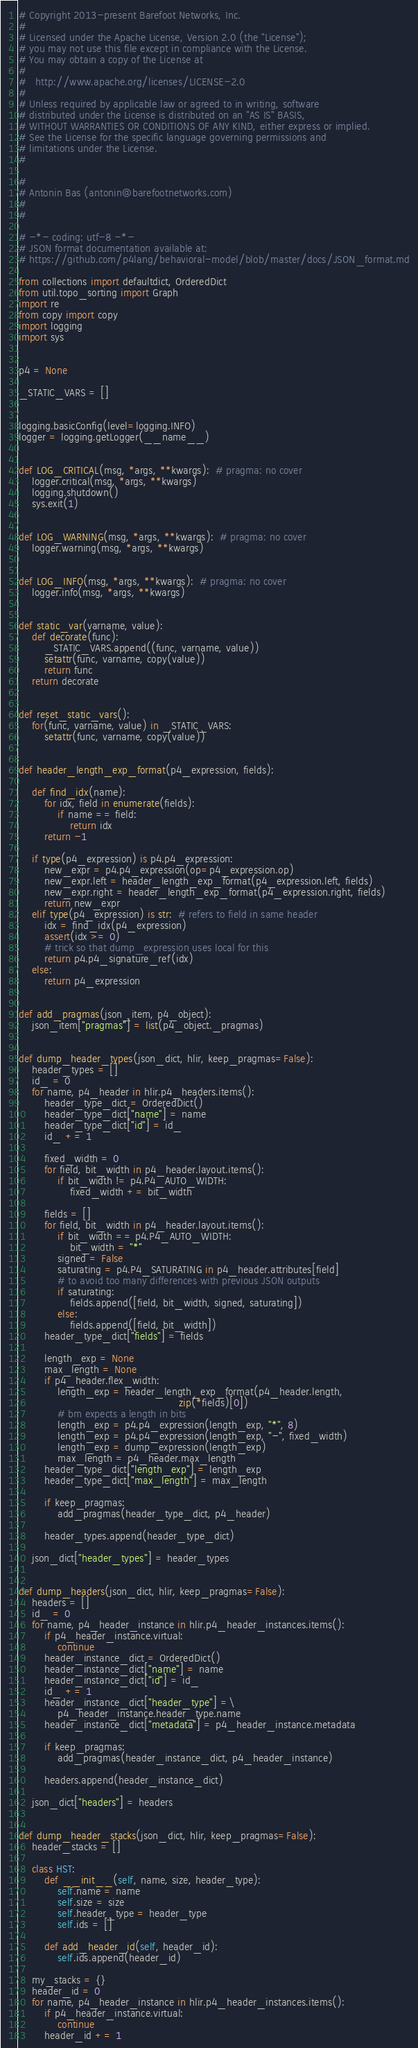<code> <loc_0><loc_0><loc_500><loc_500><_Python_># Copyright 2013-present Barefoot Networks, Inc.
#
# Licensed under the Apache License, Version 2.0 (the "License");
# you may not use this file except in compliance with the License.
# You may obtain a copy of the License at
#
#   http://www.apache.org/licenses/LICENSE-2.0
#
# Unless required by applicable law or agreed to in writing, software
# distributed under the License is distributed on an "AS IS" BASIS,
# WITHOUT WARRANTIES OR CONDITIONS OF ANY KIND, either express or implied.
# See the License for the specific language governing permissions and
# limitations under the License.
#

#
# Antonin Bas (antonin@barefootnetworks.com)
#
#

# -*- coding: utf-8 -*-
# JSON format documentation available at:
# https://github.com/p4lang/behavioral-model/blob/master/docs/JSON_format.md

from collections import defaultdict, OrderedDict
from util.topo_sorting import Graph
import re
from copy import copy
import logging
import sys


p4 = None

_STATIC_VARS = []


logging.basicConfig(level=logging.INFO)
logger = logging.getLogger(__name__)


def LOG_CRITICAL(msg, *args, **kwargs):  # pragma: no cover
    logger.critical(msg, *args, **kwargs)
    logging.shutdown()
    sys.exit(1)


def LOG_WARNING(msg, *args, **kwargs):  # pragma: no cover
    logger.warning(msg, *args, **kwargs)


def LOG_INFO(msg, *args, **kwargs):  # pragma: no cover
    logger.info(msg, *args, **kwargs)


def static_var(varname, value):
    def decorate(func):
        _STATIC_VARS.append((func, varname, value))
        setattr(func, varname, copy(value))
        return func
    return decorate


def reset_static_vars():
    for(func, varname, value) in _STATIC_VARS:
        setattr(func, varname, copy(value))


def header_length_exp_format(p4_expression, fields):

    def find_idx(name):
        for idx, field in enumerate(fields):
            if name == field:
                return idx
        return -1

    if type(p4_expression) is p4.p4_expression:
        new_expr = p4.p4_expression(op=p4_expression.op)
        new_expr.left = header_length_exp_format(p4_expression.left, fields)
        new_expr.right = header_length_exp_format(p4_expression.right, fields)
        return new_expr
    elif type(p4_expression) is str:  # refers to field in same header
        idx = find_idx(p4_expression)
        assert(idx >= 0)
        # trick so that dump_expression uses local for this
        return p4.p4_signature_ref(idx)
    else:
        return p4_expression


def add_pragmas(json_item, p4_object):
    json_item["pragmas"] = list(p4_object._pragmas)


def dump_header_types(json_dict, hlir, keep_pragmas=False):
    header_types = []
    id_ = 0
    for name, p4_header in hlir.p4_headers.items():
        header_type_dict = OrderedDict()
        header_type_dict["name"] = name
        header_type_dict["id"] = id_
        id_ += 1

        fixed_width = 0
        for field, bit_width in p4_header.layout.items():
            if bit_width != p4.P4_AUTO_WIDTH:
                fixed_width += bit_width

        fields = []
        for field, bit_width in p4_header.layout.items():
            if bit_width == p4.P4_AUTO_WIDTH:
                bit_width = "*"
            signed = False
            saturating = p4.P4_SATURATING in p4_header.attributes[field]
            # to avoid too many differences with previous JSON outputs
            if saturating:
                fields.append([field, bit_width, signed, saturating])
            else:
                fields.append([field, bit_width])
        header_type_dict["fields"] = fields

        length_exp = None
        max_length = None
        if p4_header.flex_width:
            length_exp = header_length_exp_format(p4_header.length,
                                                  zip(*fields)[0])
            # bm expects a length in bits
            length_exp = p4.p4_expression(length_exp, "*", 8)
            length_exp = p4.p4_expression(length_exp, "-", fixed_width)
            length_exp = dump_expression(length_exp)
            max_length = p4_header.max_length
        header_type_dict["length_exp"] = length_exp
        header_type_dict["max_length"] = max_length

        if keep_pragmas:
            add_pragmas(header_type_dict, p4_header)

        header_types.append(header_type_dict)

    json_dict["header_types"] = header_types


def dump_headers(json_dict, hlir, keep_pragmas=False):
    headers = []
    id_ = 0
    for name, p4_header_instance in hlir.p4_header_instances.items():
        if p4_header_instance.virtual:
            continue
        header_instance_dict = OrderedDict()
        header_instance_dict["name"] = name
        header_instance_dict["id"] = id_
        id_ += 1
        header_instance_dict["header_type"] =\
            p4_header_instance.header_type.name
        header_instance_dict["metadata"] = p4_header_instance.metadata

        if keep_pragmas:
            add_pragmas(header_instance_dict, p4_header_instance)

        headers.append(header_instance_dict)

    json_dict["headers"] = headers


def dump_header_stacks(json_dict, hlir, keep_pragmas=False):
    header_stacks = []

    class HST:
        def __init__(self, name, size, header_type):
            self.name = name
            self.size = size
            self.header_type = header_type
            self.ids = []

        def add_header_id(self, header_id):
            self.ids.append(header_id)

    my_stacks = {}
    header_id = 0
    for name, p4_header_instance in hlir.p4_header_instances.items():
        if p4_header_instance.virtual:
            continue
        header_id += 1</code> 